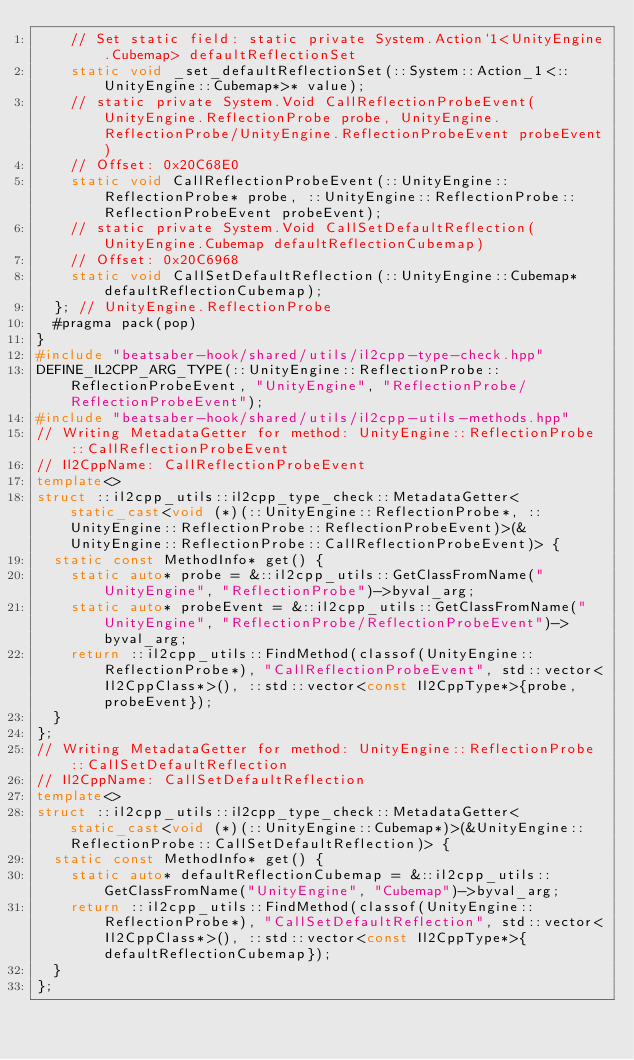<code> <loc_0><loc_0><loc_500><loc_500><_C++_>    // Set static field: static private System.Action`1<UnityEngine.Cubemap> defaultReflectionSet
    static void _set_defaultReflectionSet(::System::Action_1<::UnityEngine::Cubemap*>* value);
    // static private System.Void CallReflectionProbeEvent(UnityEngine.ReflectionProbe probe, UnityEngine.ReflectionProbe/UnityEngine.ReflectionProbeEvent probeEvent)
    // Offset: 0x20C68E0
    static void CallReflectionProbeEvent(::UnityEngine::ReflectionProbe* probe, ::UnityEngine::ReflectionProbe::ReflectionProbeEvent probeEvent);
    // static private System.Void CallSetDefaultReflection(UnityEngine.Cubemap defaultReflectionCubemap)
    // Offset: 0x20C6968
    static void CallSetDefaultReflection(::UnityEngine::Cubemap* defaultReflectionCubemap);
  }; // UnityEngine.ReflectionProbe
  #pragma pack(pop)
}
#include "beatsaber-hook/shared/utils/il2cpp-type-check.hpp"
DEFINE_IL2CPP_ARG_TYPE(::UnityEngine::ReflectionProbe::ReflectionProbeEvent, "UnityEngine", "ReflectionProbe/ReflectionProbeEvent");
#include "beatsaber-hook/shared/utils/il2cpp-utils-methods.hpp"
// Writing MetadataGetter for method: UnityEngine::ReflectionProbe::CallReflectionProbeEvent
// Il2CppName: CallReflectionProbeEvent
template<>
struct ::il2cpp_utils::il2cpp_type_check::MetadataGetter<static_cast<void (*)(::UnityEngine::ReflectionProbe*, ::UnityEngine::ReflectionProbe::ReflectionProbeEvent)>(&UnityEngine::ReflectionProbe::CallReflectionProbeEvent)> {
  static const MethodInfo* get() {
    static auto* probe = &::il2cpp_utils::GetClassFromName("UnityEngine", "ReflectionProbe")->byval_arg;
    static auto* probeEvent = &::il2cpp_utils::GetClassFromName("UnityEngine", "ReflectionProbe/ReflectionProbeEvent")->byval_arg;
    return ::il2cpp_utils::FindMethod(classof(UnityEngine::ReflectionProbe*), "CallReflectionProbeEvent", std::vector<Il2CppClass*>(), ::std::vector<const Il2CppType*>{probe, probeEvent});
  }
};
// Writing MetadataGetter for method: UnityEngine::ReflectionProbe::CallSetDefaultReflection
// Il2CppName: CallSetDefaultReflection
template<>
struct ::il2cpp_utils::il2cpp_type_check::MetadataGetter<static_cast<void (*)(::UnityEngine::Cubemap*)>(&UnityEngine::ReflectionProbe::CallSetDefaultReflection)> {
  static const MethodInfo* get() {
    static auto* defaultReflectionCubemap = &::il2cpp_utils::GetClassFromName("UnityEngine", "Cubemap")->byval_arg;
    return ::il2cpp_utils::FindMethod(classof(UnityEngine::ReflectionProbe*), "CallSetDefaultReflection", std::vector<Il2CppClass*>(), ::std::vector<const Il2CppType*>{defaultReflectionCubemap});
  }
};
</code> 